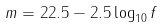Convert formula to latex. <formula><loc_0><loc_0><loc_500><loc_500>m = 2 2 . 5 - 2 . 5 \log _ { 1 0 } f</formula> 